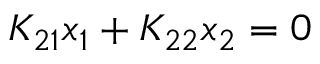Convert formula to latex. <formula><loc_0><loc_0><loc_500><loc_500>K _ { 2 1 } x _ { 1 } + K _ { 2 2 } x _ { 2 } = 0</formula> 